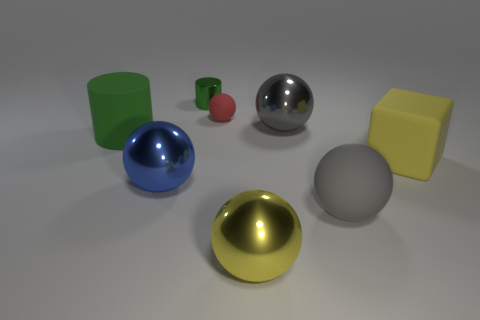Is there any other thing that is the same shape as the big gray rubber object?
Keep it short and to the point. Yes. Do the metal sphere behind the block and the large block have the same color?
Your answer should be very brief. No. What size is the other metallic thing that is the same shape as the big green object?
Keep it short and to the point. Small. What number of big objects have the same material as the yellow sphere?
Provide a short and direct response. 2. There is a yellow object that is behind the rubber thing in front of the yellow block; is there a blue metallic thing to the right of it?
Offer a terse response. No. What is the shape of the tiny matte object?
Make the answer very short. Sphere. Is the material of the large yellow thing that is to the left of the big yellow rubber cube the same as the object that is left of the blue object?
Keep it short and to the point. No. What number of other rubber cylinders are the same color as the tiny cylinder?
Ensure brevity in your answer.  1. There is a big object that is left of the tiny metal thing and behind the yellow cube; what is its shape?
Give a very brief answer. Cylinder. What color is the metallic ball that is both on the right side of the large blue metallic ball and in front of the large yellow block?
Keep it short and to the point. Yellow. 